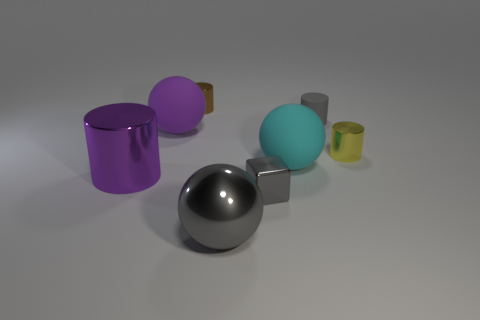Add 2 small green metal things. How many objects exist? 10 Subtract all blocks. How many objects are left? 7 Add 6 cyan matte balls. How many cyan matte balls are left? 7 Add 7 cyan rubber cylinders. How many cyan rubber cylinders exist? 7 Subtract 0 red blocks. How many objects are left? 8 Subtract all tiny brown metallic cylinders. Subtract all large gray shiny objects. How many objects are left? 6 